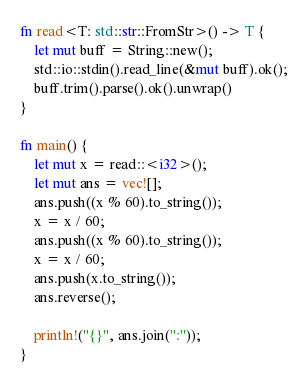Convert code to text. <code><loc_0><loc_0><loc_500><loc_500><_Rust_>fn read<T: std::str::FromStr>() -> T {
    let mut buff = String::new();
    std::io::stdin().read_line(&mut buff).ok();
    buff.trim().parse().ok().unwrap()
}

fn main() {
    let mut x = read::<i32>();
    let mut ans = vec![];
    ans.push((x % 60).to_string());
    x = x / 60;
    ans.push((x % 60).to_string());
    x = x / 60;
    ans.push(x.to_string());
    ans.reverse();
    
    println!("{}", ans.join(":"));
}

</code> 